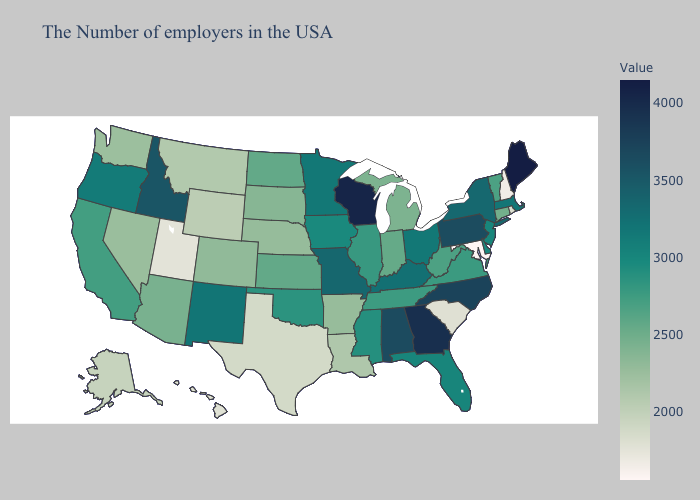Among the states that border Illinois , does Indiana have the highest value?
Short answer required. No. Among the states that border Michigan , which have the highest value?
Give a very brief answer. Wisconsin. Which states have the lowest value in the Northeast?
Concise answer only. New Hampshire. Is the legend a continuous bar?
Short answer required. Yes. Among the states that border New Jersey , does Pennsylvania have the highest value?
Answer briefly. Yes. 